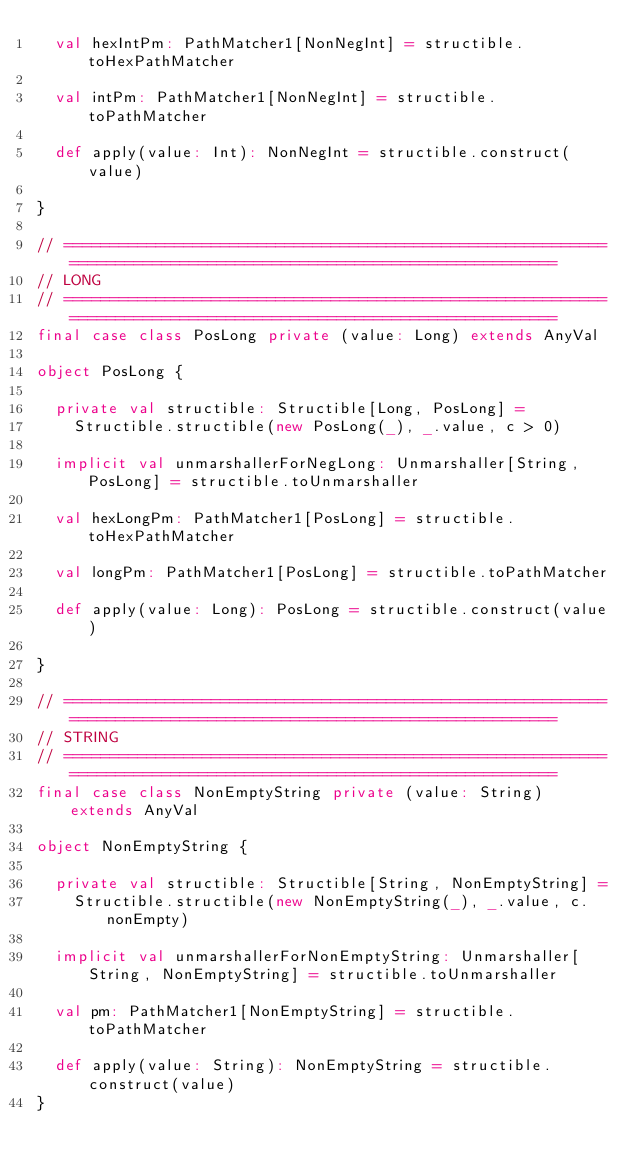<code> <loc_0><loc_0><loc_500><loc_500><_Scala_>  val hexIntPm: PathMatcher1[NonNegInt] = structible.toHexPathMatcher

  val intPm: PathMatcher1[NonNegInt] = structible.toPathMatcher

  def apply(value: Int): NonNegInt = structible.construct(value)

}

// ================================================================================================================
// LONG
// ================================================================================================================
final case class PosLong private (value: Long) extends AnyVal

object PosLong {

  private val structible: Structible[Long, PosLong] =
    Structible.structible(new PosLong(_), _.value, c > 0)

  implicit val unmarshallerForNegLong: Unmarshaller[String, PosLong] = structible.toUnmarshaller

  val hexLongPm: PathMatcher1[PosLong] = structible.toHexPathMatcher

  val longPm: PathMatcher1[PosLong] = structible.toPathMatcher

  def apply(value: Long): PosLong = structible.construct(value)

}

// ================================================================================================================
// STRING
// ================================================================================================================
final case class NonEmptyString private (value: String) extends AnyVal

object NonEmptyString {

  private val structible: Structible[String, NonEmptyString] =
    Structible.structible(new NonEmptyString(_), _.value, c.nonEmpty)

  implicit val unmarshallerForNonEmptyString: Unmarshaller[String, NonEmptyString] = structible.toUnmarshaller

  val pm: PathMatcher1[NonEmptyString] = structible.toPathMatcher

  def apply(value: String): NonEmptyString = structible.construct(value)
}
</code> 